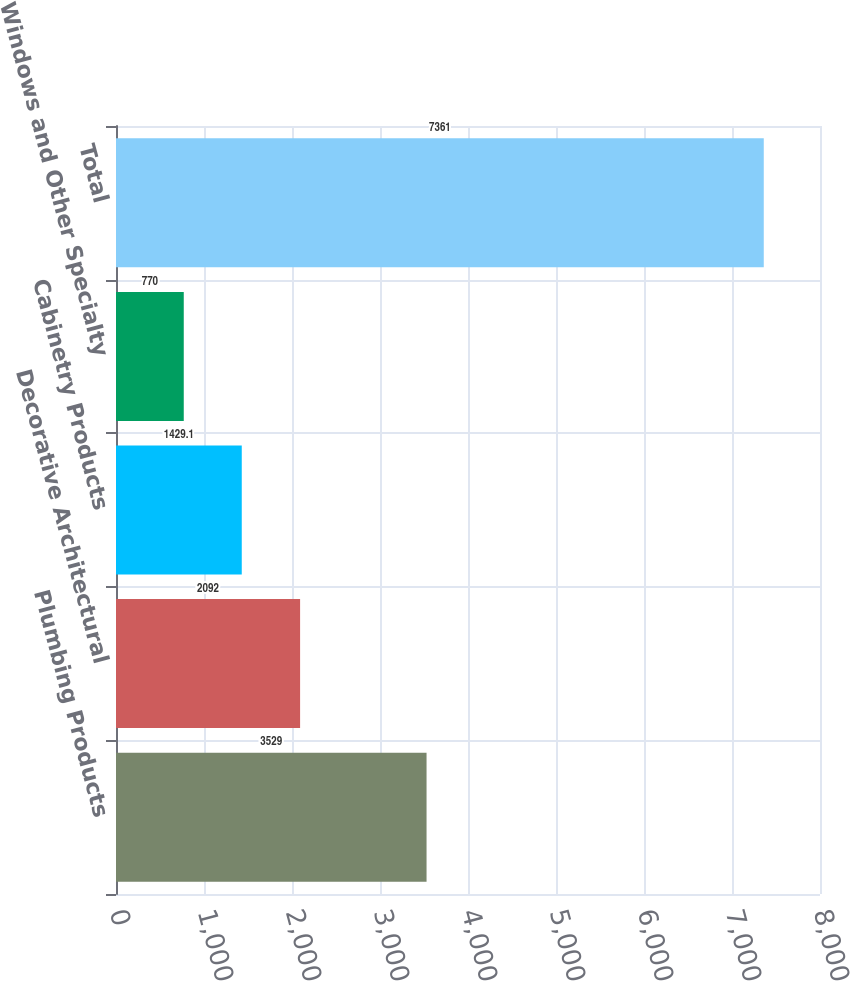<chart> <loc_0><loc_0><loc_500><loc_500><bar_chart><fcel>Plumbing Products<fcel>Decorative Architectural<fcel>Cabinetry Products<fcel>Windows and Other Specialty<fcel>Total<nl><fcel>3529<fcel>2092<fcel>1429.1<fcel>770<fcel>7361<nl></chart> 